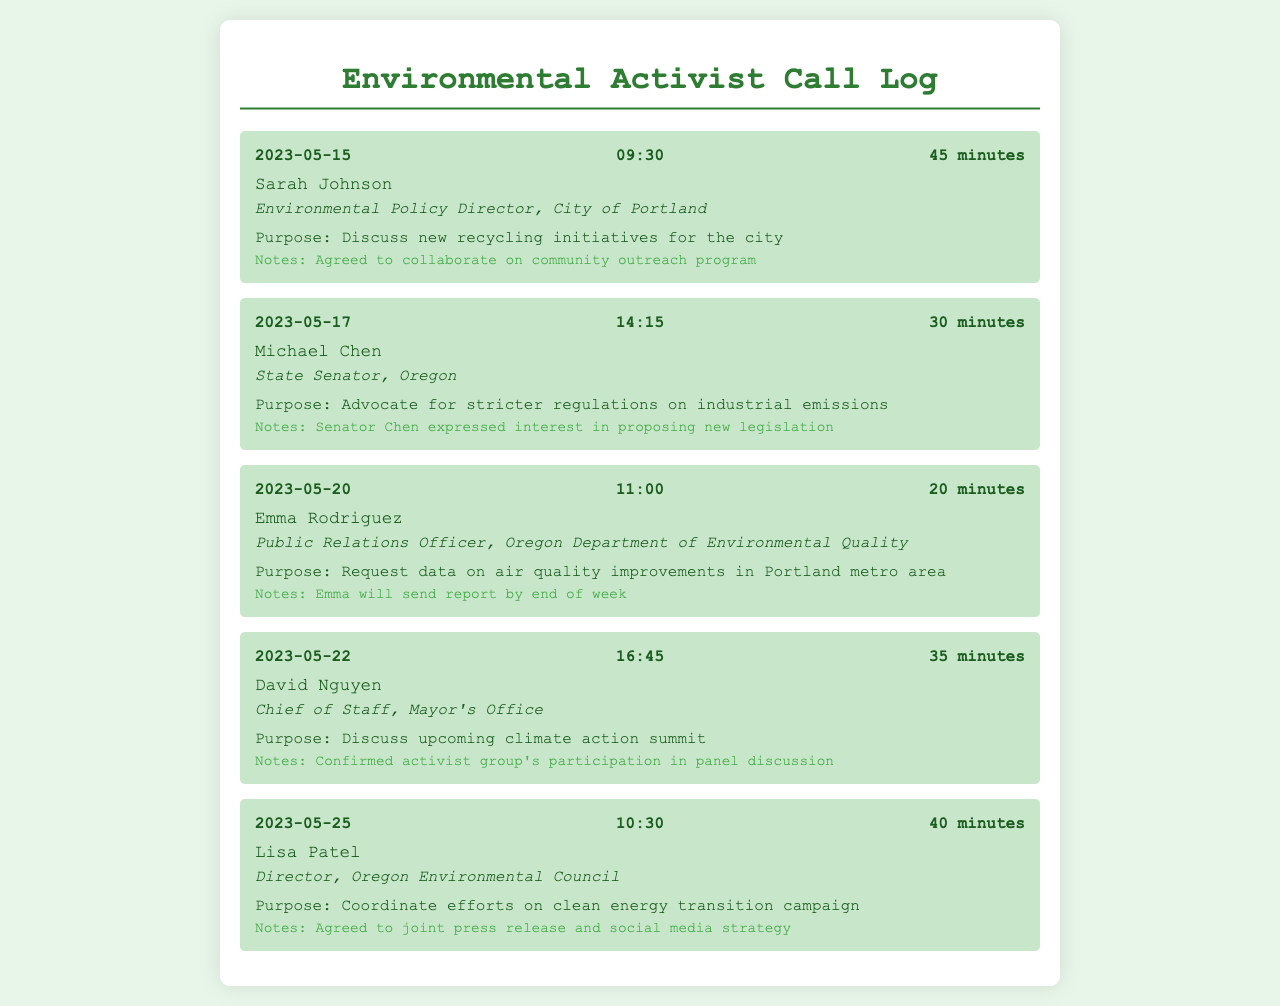What is the date of the first call? The first call is logged on May 15, 2023.
Answer: May 15, 2023 Who is the contact for the discussion about the climate action summit? David Nguyen is the Chief of Staff at the Mayor's Office and discussed the climate action summit.
Answer: David Nguyen What was the duration of the call with Sarah Johnson? The call with Sarah Johnson lasted 45 minutes.
Answer: 45 minutes What initiative was discussed with Michael Chen? The discussion with Michael Chen was about advocating for stricter regulations on industrial emissions.
Answer: Stricter regulations on industrial emissions How many calls were made in total? There are five call entries recorded in the document.
Answer: 5 What will Emma Rodriguez send by the end of the week? Emma Rodriguez will send a report on air quality improvements.
Answer: Report Which call involved coordinating efforts on a campaign? The call with Lisa Patel involved coordinating efforts on the clean energy transition campaign.
Answer: Clean energy transition campaign What was a key outcome from the call with David Nguyen? A key outcome was the confirmation of the activist group's participation in a panel discussion.
Answer: Confirmation of participation What is Sarah Johnson's title? Sarah Johnson's title is Environmental Policy Director.
Answer: Environmental Policy Director 